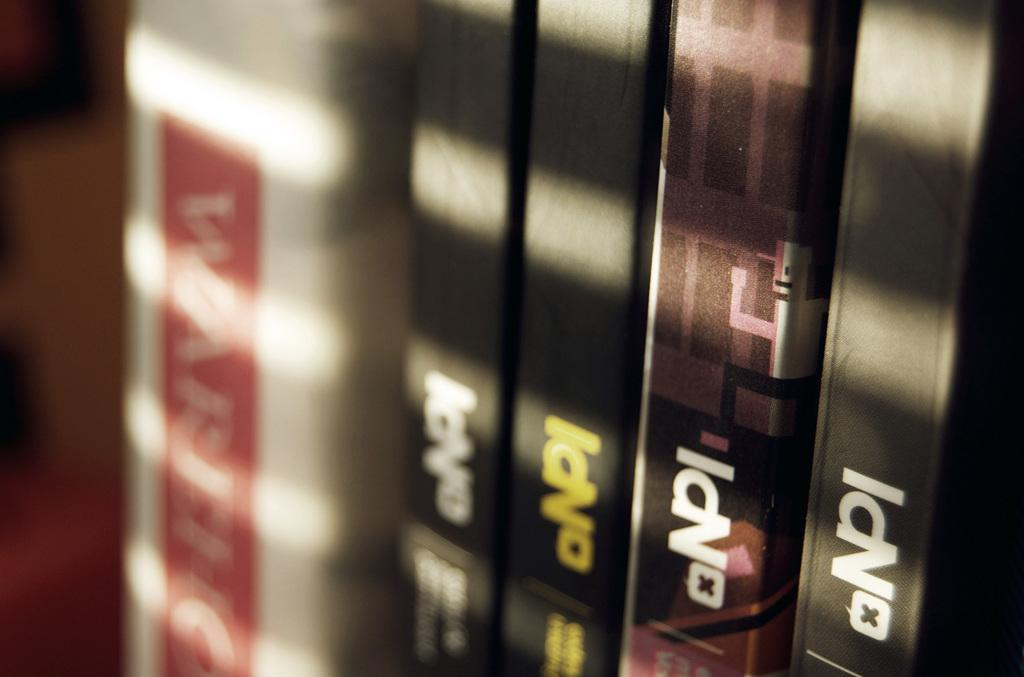<image>
Relay a brief, clear account of the picture shown. A stack of four DVD cases titled NPI 